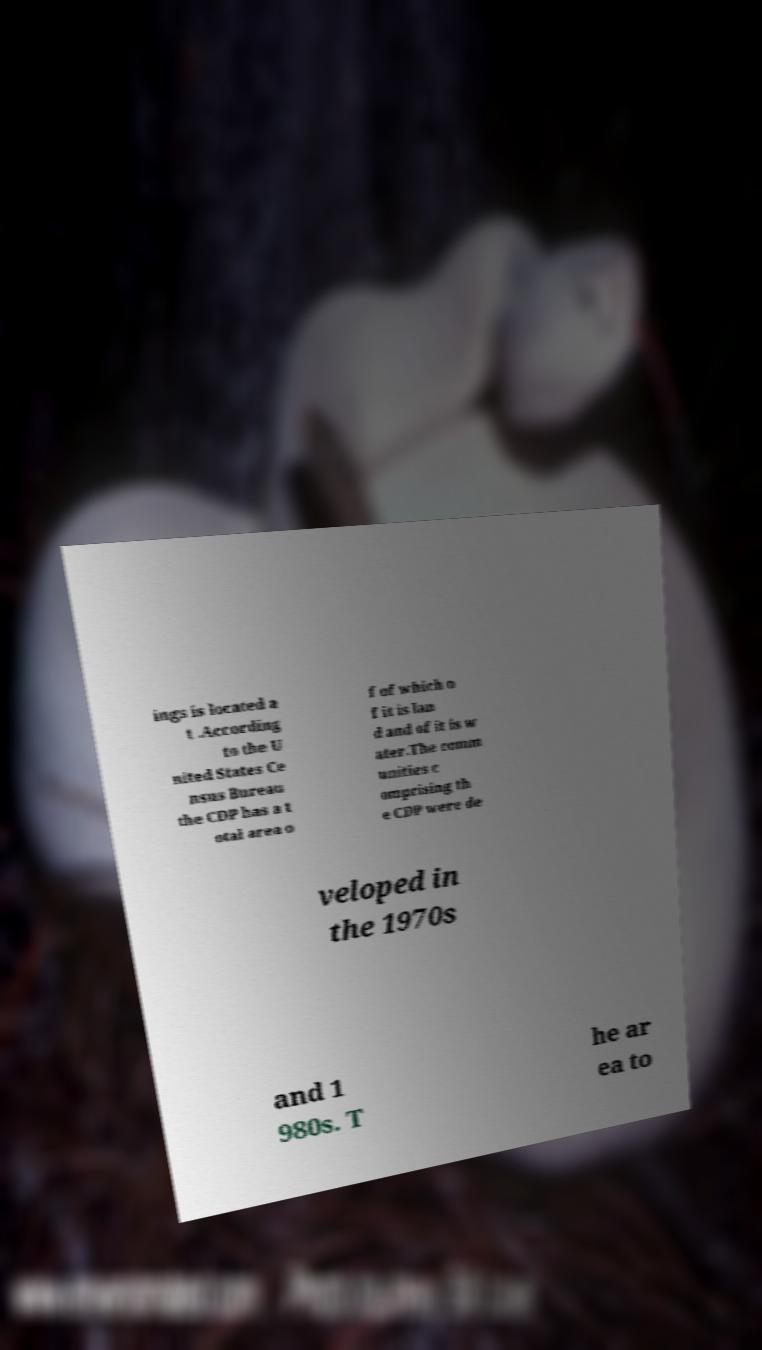For documentation purposes, I need the text within this image transcribed. Could you provide that? ings is located a t .According to the U nited States Ce nsus Bureau the CDP has a t otal area o f of which o f it is lan d and of it is w ater.The comm unities c omprising th e CDP were de veloped in the 1970s and 1 980s. T he ar ea to 